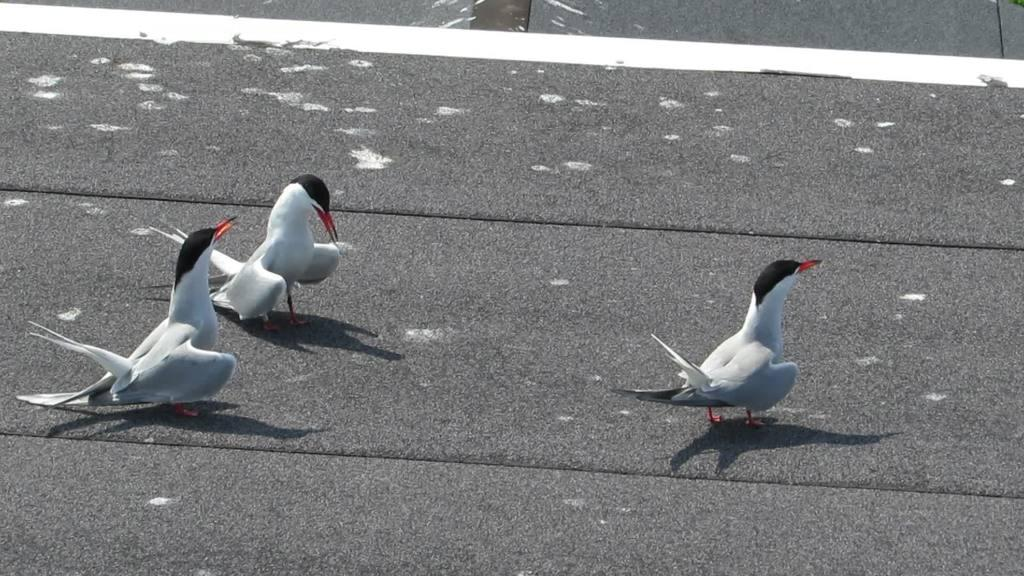How many birds can be seen in the image? There are three birds in the image. What are the birds doing in the image? The birds are on a surface. What is the birds' desire to twist the ray in the image? There is no mention of a desire, twist, or ray in the image. The image only features three birds on a surface. 